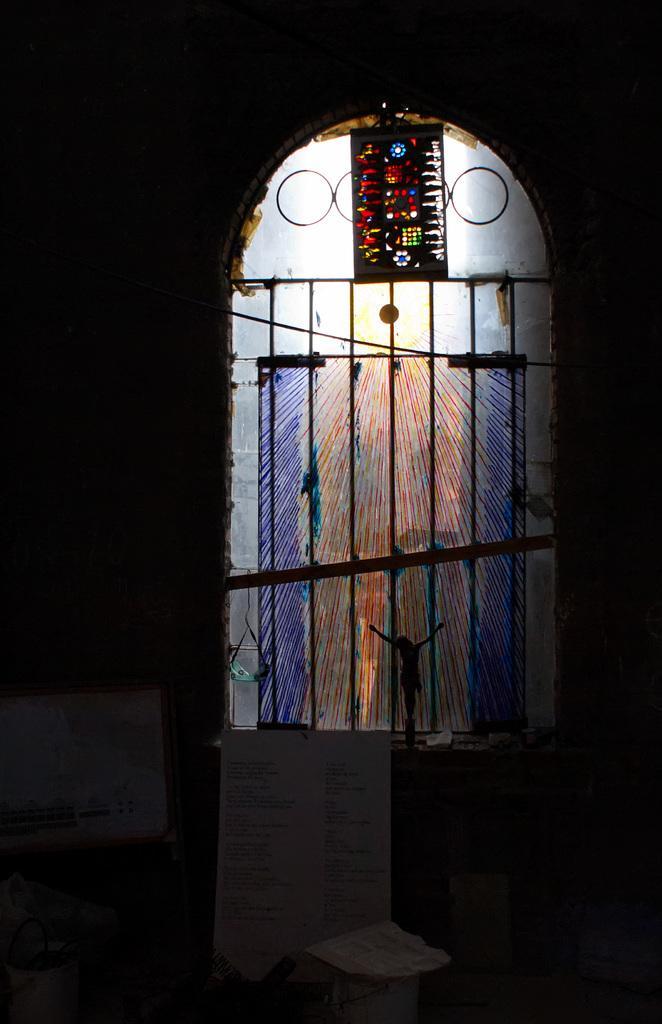Could you give a brief overview of what you see in this image? In this picture I can see a frame, board, toy and some other objects, and in the background there is a window with iron grilles. 